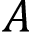<formula> <loc_0><loc_0><loc_500><loc_500>A</formula> 